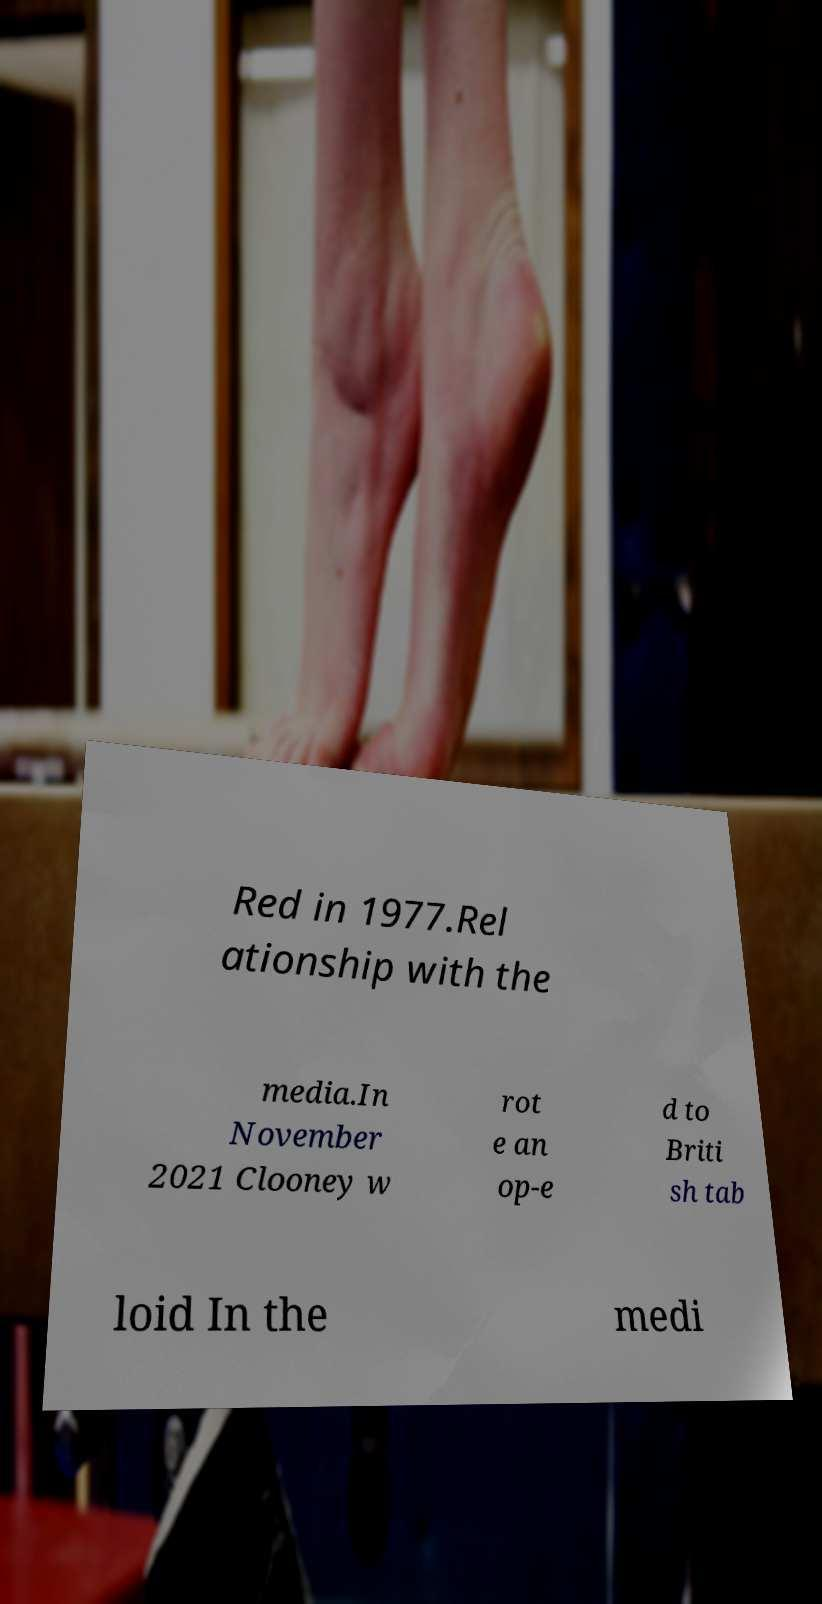Could you assist in decoding the text presented in this image and type it out clearly? Red in 1977.Rel ationship with the media.In November 2021 Clooney w rot e an op-e d to Briti sh tab loid In the medi 